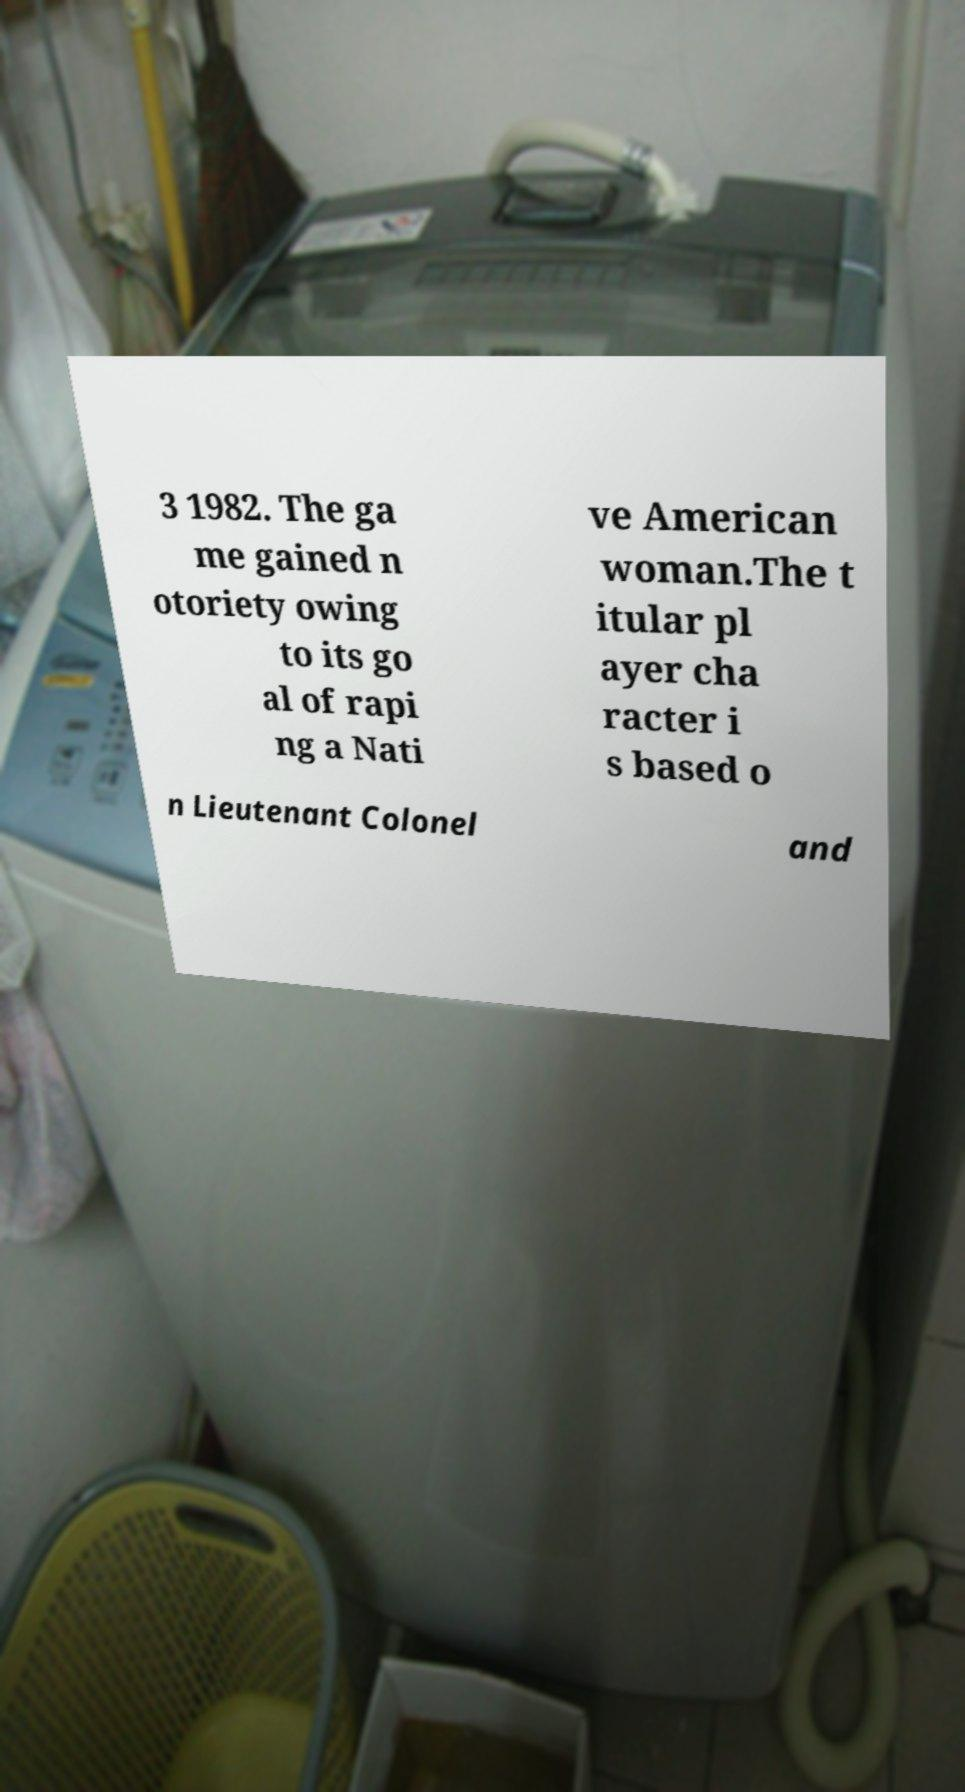There's text embedded in this image that I need extracted. Can you transcribe it verbatim? 3 1982. The ga me gained n otoriety owing to its go al of rapi ng a Nati ve American woman.The t itular pl ayer cha racter i s based o n Lieutenant Colonel and 